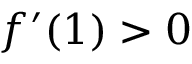Convert formula to latex. <formula><loc_0><loc_0><loc_500><loc_500>f ^ { \prime } ( 1 ) > 0</formula> 